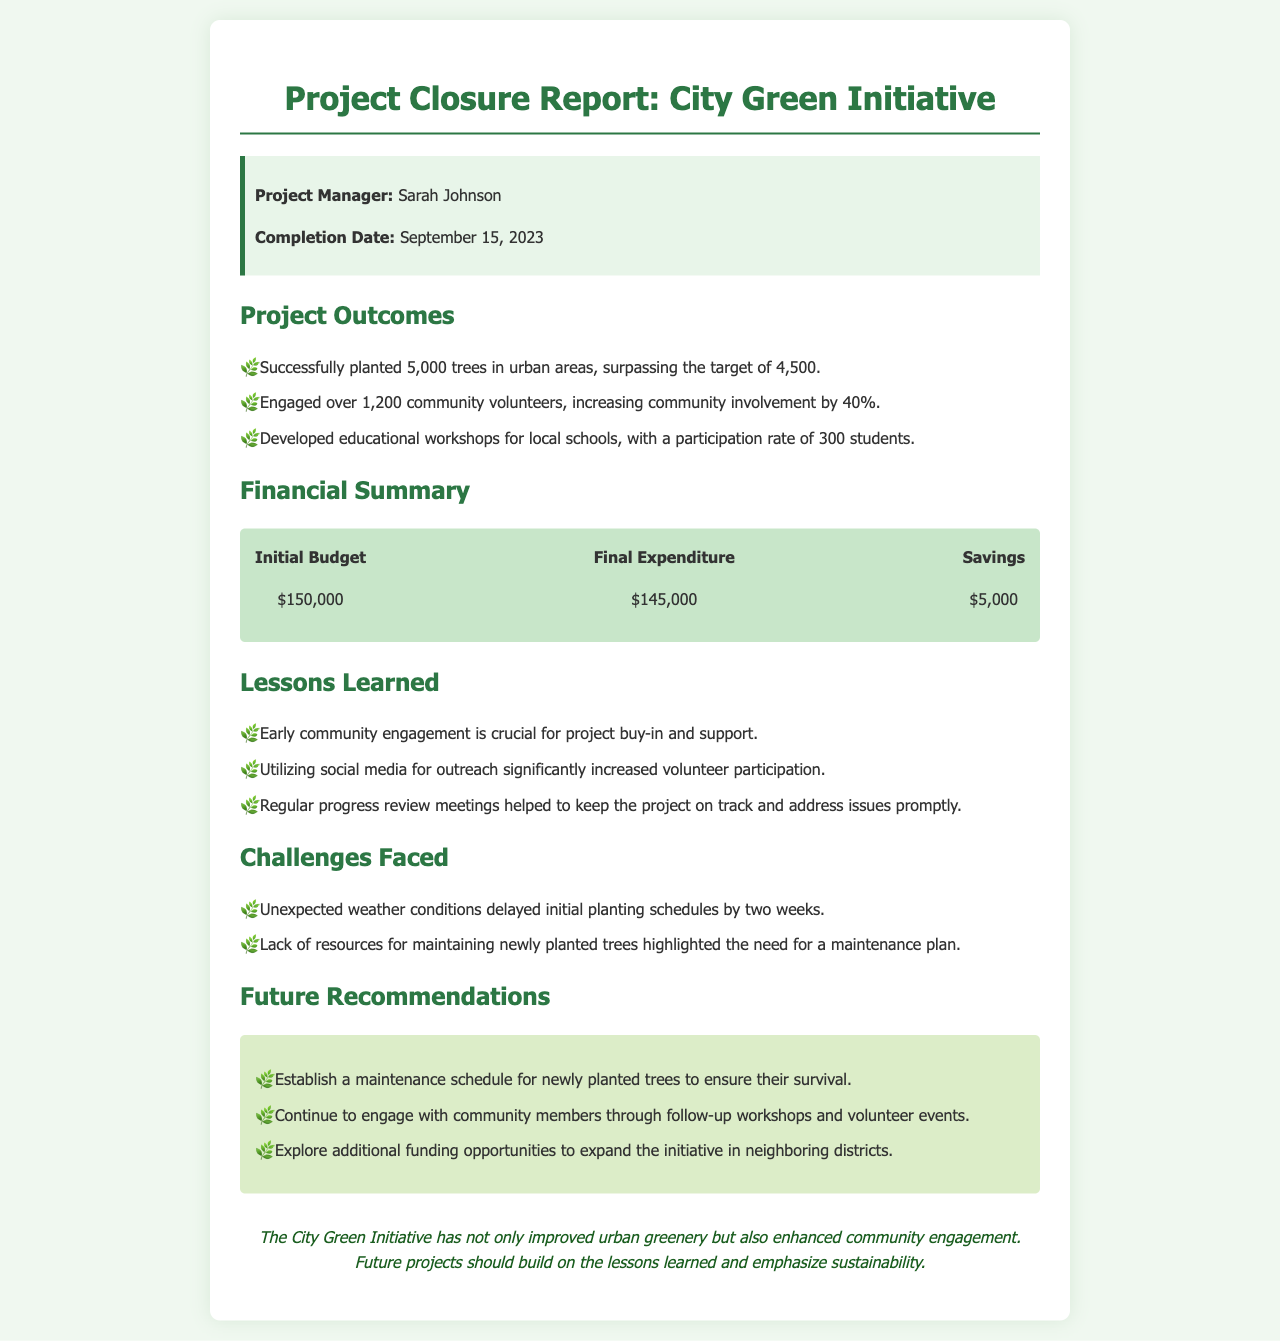what is the name of the project manager? The project manager is listed at the top of the document section under the "info-box," which states Sarah Johnson.
Answer: Sarah Johnson when was the project completed? The completion date is mentioned in the "info-box" as September 15, 2023.
Answer: September 15, 2023 how many trees were planted in total? The document states that 5,000 trees were successfully planted, which is the specific outcome highlighted.
Answer: 5,000 what was the initial budget for the project? The initial budget is found in the "Financial Summary" section, which lists it as $150,000.
Answer: $150,000 what percentage increase in community involvement was achieved? The report mentions a 40% increase in community involvement as part of the outcomes.
Answer: 40% what key lesson was learned about community engagement? One of the lessons learned states that early community engagement is crucial for project buy-in and support.
Answer: Early community engagement what was one of the challenges faced during the project? The section titled "Challenges Faced" indicates that unexpected weather conditions were a major challenge.
Answer: Unexpected weather conditions what is one future recommendation made? The recommendations section suggests establishing a maintenance schedule for newly planted trees as a future action.
Answer: Establish a maintenance schedule how many community volunteers engaged in the project? The document states that over 1,200 community volunteers were engaged during the project.
Answer: 1,200 what was the financial savings from the project? The financial summary lists savings of $5,000, which can be reported as a successful financial outcome.
Answer: $5,000 